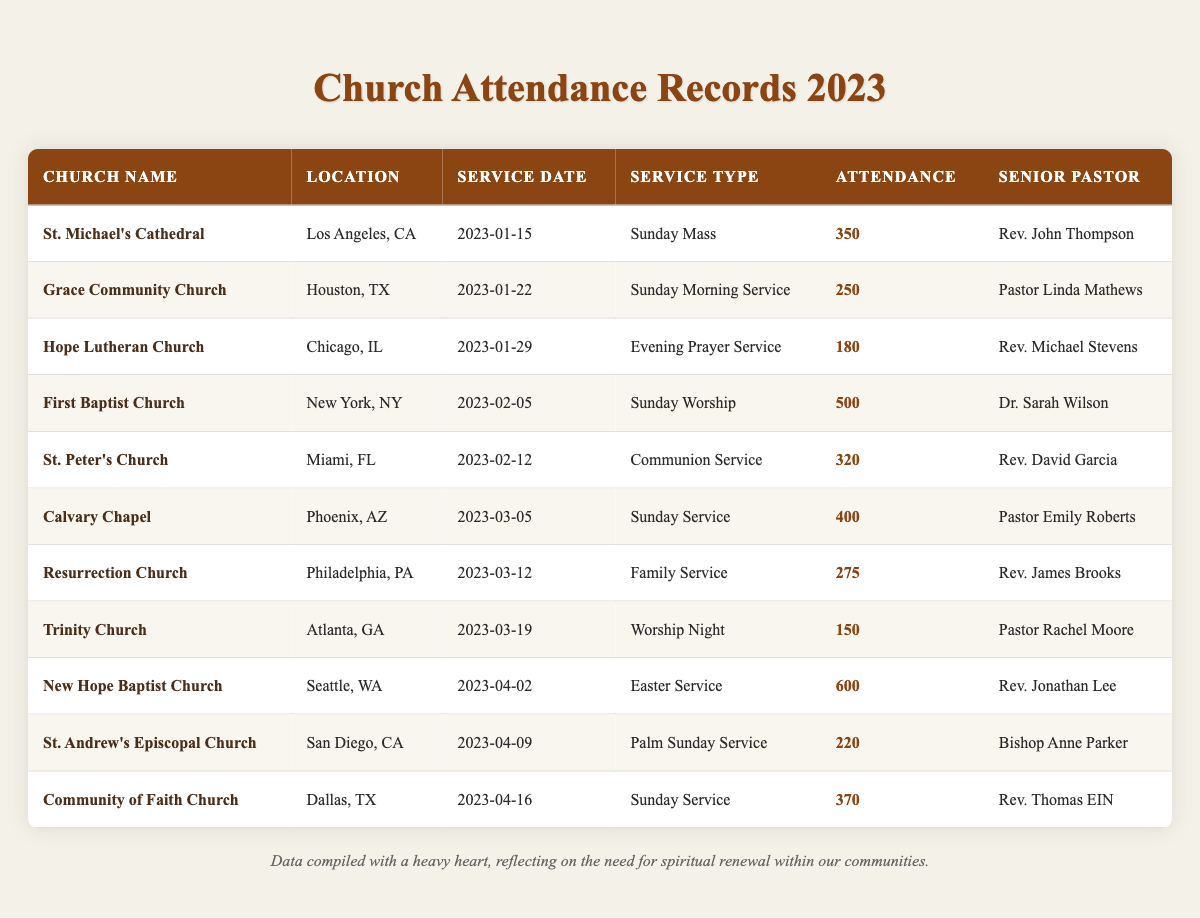What is the attendance of St. Michael's Cathedral on January 15, 2023? The table lists St. Michael's Cathedral with an attendance of 350 on January 15, 2023.
Answer: 350 Which church had the highest attendance in the records provided? The highest attendance recorded in the table is 600 at New Hope Baptist Church on April 2, 2023.
Answer: New Hope Baptist Church How many services had an attendance of over 300 people? By reviewing the table, the churches with over 300 attendance are St. Peter's Church (320), First Baptist Church (500), Calvary Chapel (400), New Hope Baptist Church (600), and Community of Faith Church (370). This makes a total of 5 services.
Answer: 5 Was there a service on March 19, 2023? The table shows that Trinity Church held a service on March 19, 2023.
Answer: Yes What is the average attendance across all church services listed? To find the average, sum up all attendance values: 350 + 250 + 180 + 500 + 320 + 400 + 275 + 150 + 600 + 220 + 370 = 3125. There are 11 services, so the average attendance is 3125 / 11 = 284.09, rounded to the nearest whole number is 284.
Answer: 284 Which church had the lowest attendance and what was the number? The table lists Trinity Church with the lowest attendance of 150 on March 19, 2023.
Answer: 150 Did any church have more than 500 attendees? Checking the data, New Hope Baptist Church is the only church with over 500 attendees, recorded at 600.
Answer: Yes What is the difference in attendance between the highest and lowest attended services? The highest attendance is 600 (New Hope Baptist Church) and the lowest is 150 (Trinity Church). The difference is 600 - 150 = 450.
Answer: 450 